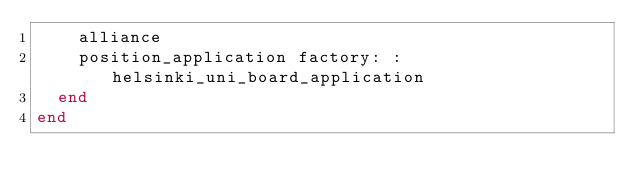<code> <loc_0><loc_0><loc_500><loc_500><_Ruby_>    alliance
    position_application factory: :helsinki_uni_board_application
  end
end
</code> 